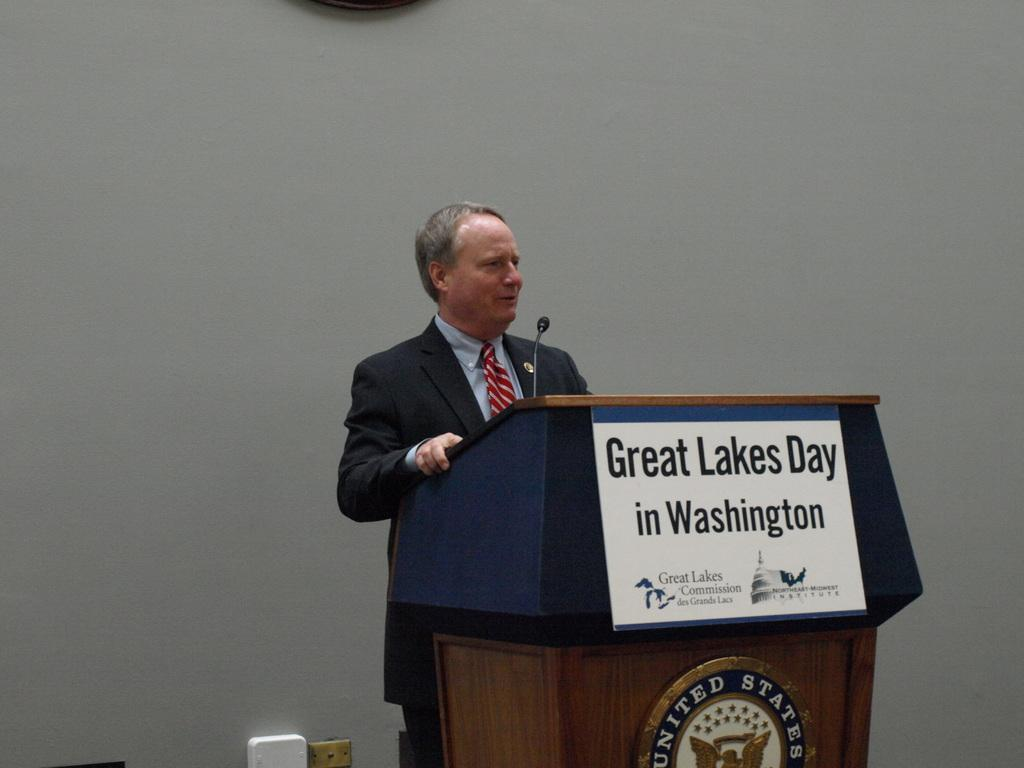<image>
Render a clear and concise summary of the photo. Man is talking about washington in a speech. 